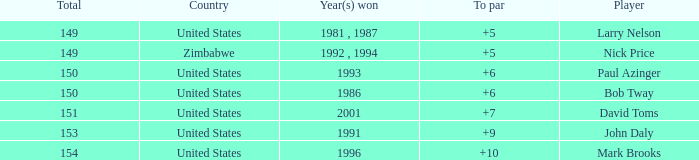What is the total for 1986 with a to par higher than 6? 0.0. Can you give me this table as a dict? {'header': ['Total', 'Country', 'Year(s) won', 'To par', 'Player'], 'rows': [['149', 'United States', '1981 , 1987', '+5', 'Larry Nelson'], ['149', 'Zimbabwe', '1992 , 1994', '+5', 'Nick Price'], ['150', 'United States', '1993', '+6', 'Paul Azinger'], ['150', 'United States', '1986', '+6', 'Bob Tway'], ['151', 'United States', '2001', '+7', 'David Toms'], ['153', 'United States', '1991', '+9', 'John Daly'], ['154', 'United States', '1996', '+10', 'Mark Brooks']]} 